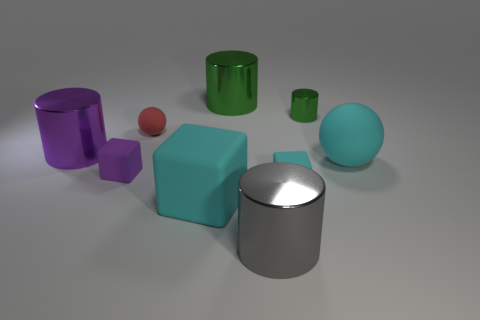Subtract all gray cylinders. How many cylinders are left? 3 Subtract 3 cylinders. How many cylinders are left? 1 Subtract all purple blocks. How many blocks are left? 2 Subtract all blocks. How many objects are left? 6 Subtract all red balls. How many purple cubes are left? 1 Add 9 large gray cylinders. How many large gray cylinders exist? 10 Subtract 0 green blocks. How many objects are left? 9 Subtract all gray balls. Subtract all gray cylinders. How many balls are left? 2 Subtract all big red objects. Subtract all tiny red things. How many objects are left? 8 Add 3 gray things. How many gray things are left? 4 